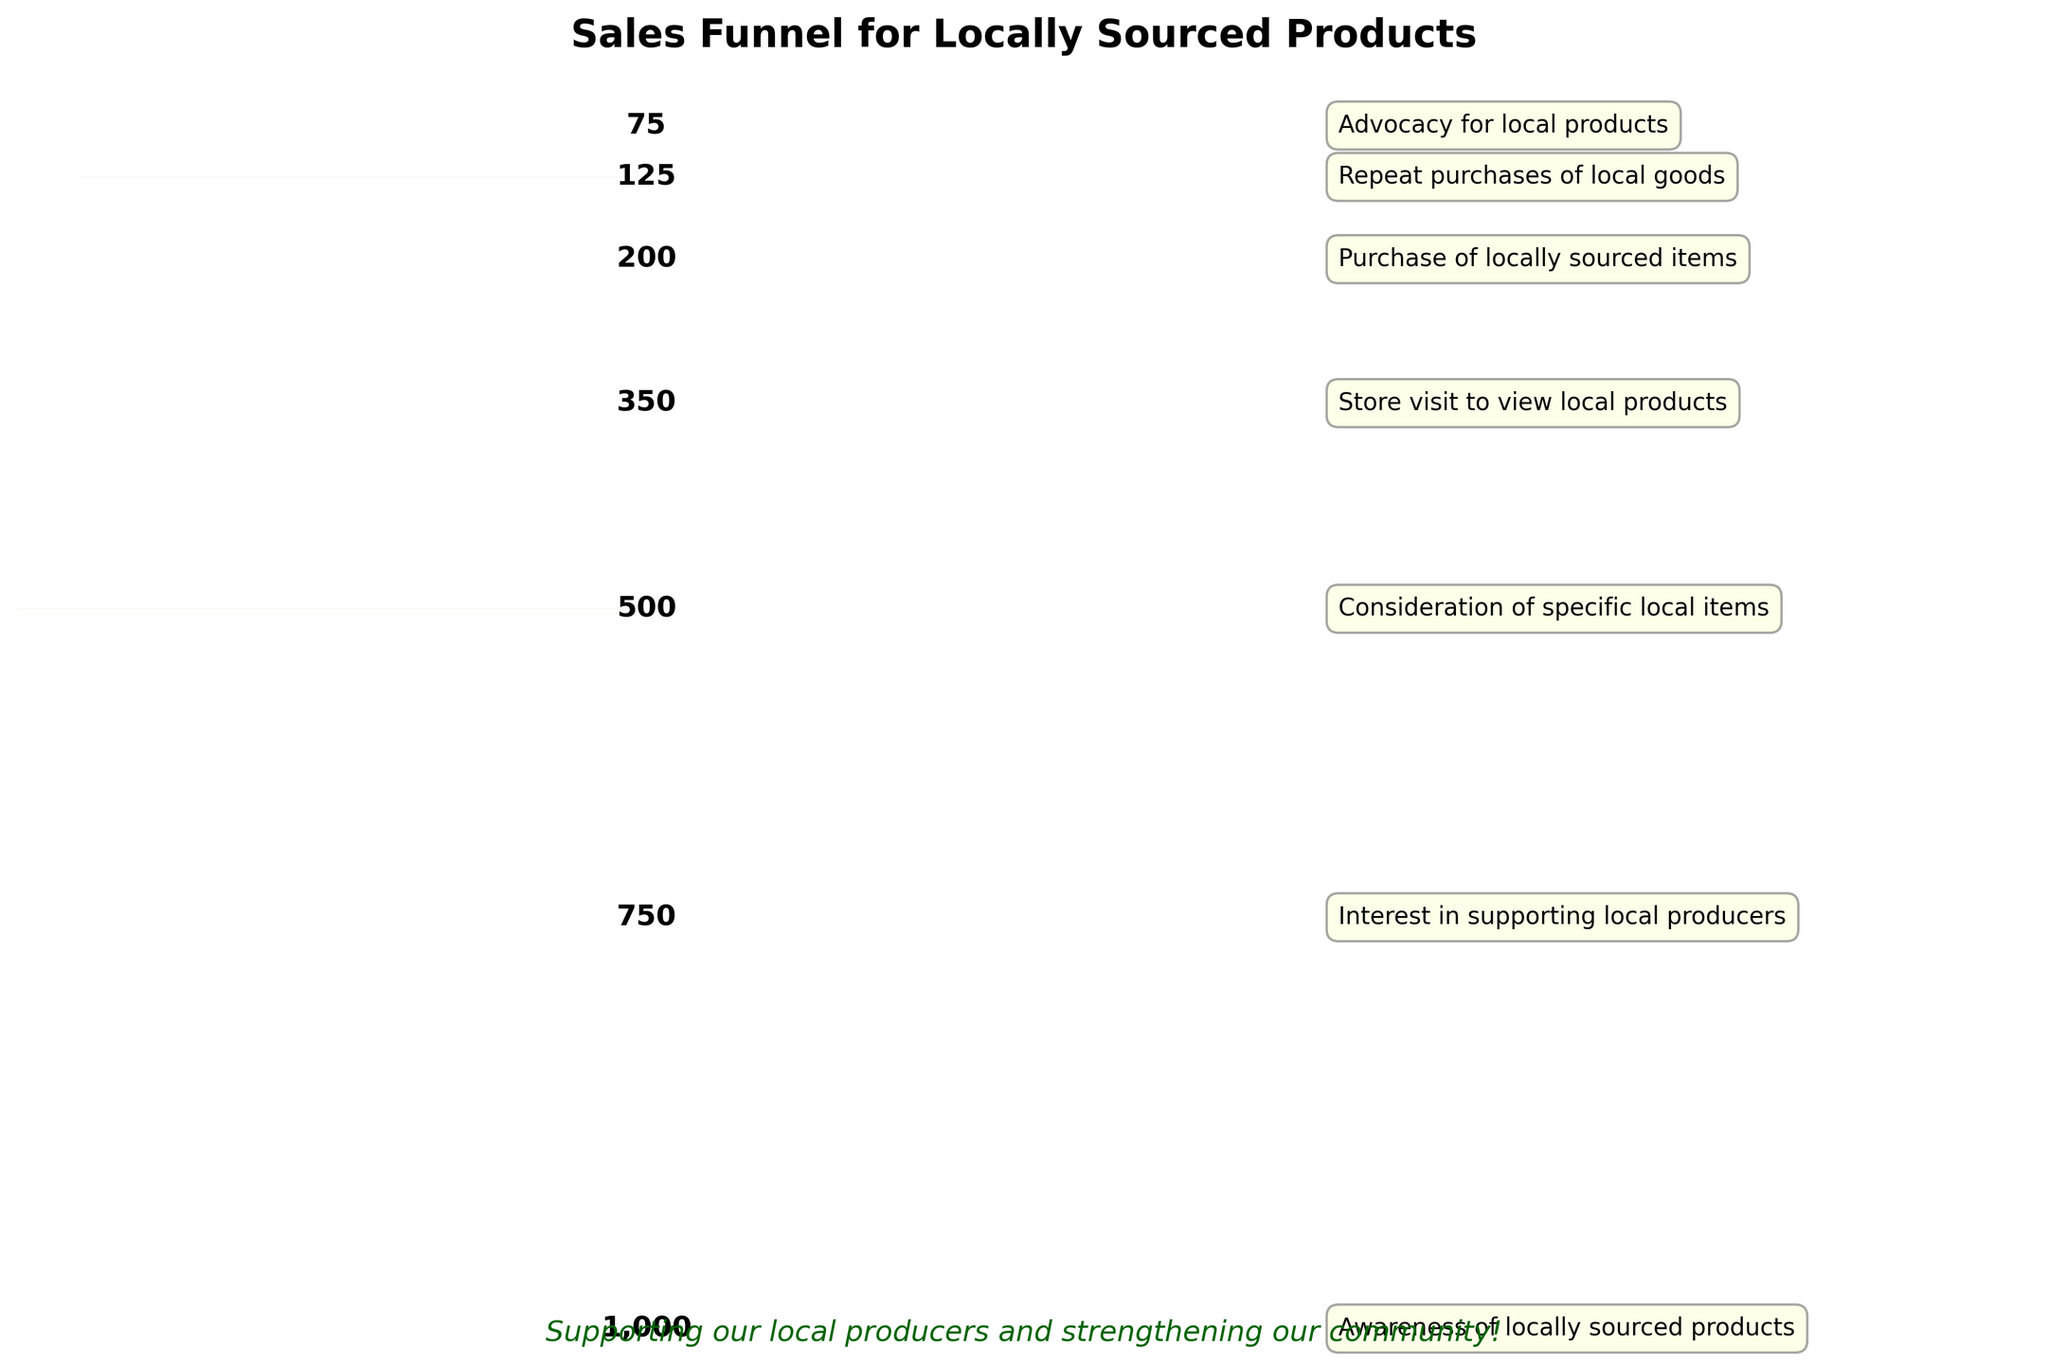How many stages are there in the funnel? The funnel chart has labeled segments representing different stages of the sales funnel. Counting them from top to bottom shows there are seven stages.
Answer: Seven stages Which stage has the highest count of people? The count of people decreases from top to bottom in a funnel chart making the top segment, 'Awareness of locally sourced products', the one with the highest count at 1000 people.
Answer: Awareness of locally sourced products What percentage of people moved from 'Awareness of locally sourced products' to 'Interest in supporting local producers'? The percentage is calculated by dividing the count of the second stage by the count of the first stage and multiplying by 100. So, (750 / 1000) * 100 = 75%.
Answer: 75% How many more people considered specific local items over those who visited the store to view local products? Subtract the count of the 'Store visit to view local products' stage (350) from the 'Consideration of specific local items' stage (500). So, 500 - 350 = 150.
Answer: 150 people What is the ratio of people advocating for local products to those making repeat purchases? The ratio can be determined by dividing the count of the 'Advocacy for local products' stage (75) by the count of the 'Repeat purchases of local goods' stage (125). Simplifying, 75 / 125 = 0.6.
Answer: 0.6 How many stages have counts less than 400? By examining the chart, the stages with counts below 400 are 'Store visit to view local products' (350), 'Purchase of locally sourced items' (200), 'Repeat purchases of local goods' (125), and 'Advocacy for local products' (75). Hence, there are 4 such stages.
Answer: Four stages What is the average count of people across all stages? To find the average, sum the counts of all stages and divide by the number of stages. The total sum = 1000 + 750 + 500 + 350 + 200 + 125 + 75 = 3000. Divide by 7 stages: 3000 / 7 ≈ 428.57.
Answer: Approximately 428.57 Which transition stage has the largest drop in people? Comparing the drop between consecutive stages, the largest decrease is between 'Awareness of locally sourced products' (1000) and 'Interest in supporting local producers' (750): 1000 - 750 = 250 people.
Answer: From Awareness to Interest By how much did the count decrease from 'Purchase of locally sourced items' to 'Repeat purchases of local goods'? Subtract the count of 'Repeat purchases of local goods' (125) from 'Purchase of locally sourced items' (200). 200 - 125 = 75 people.
Answer: 75 people 